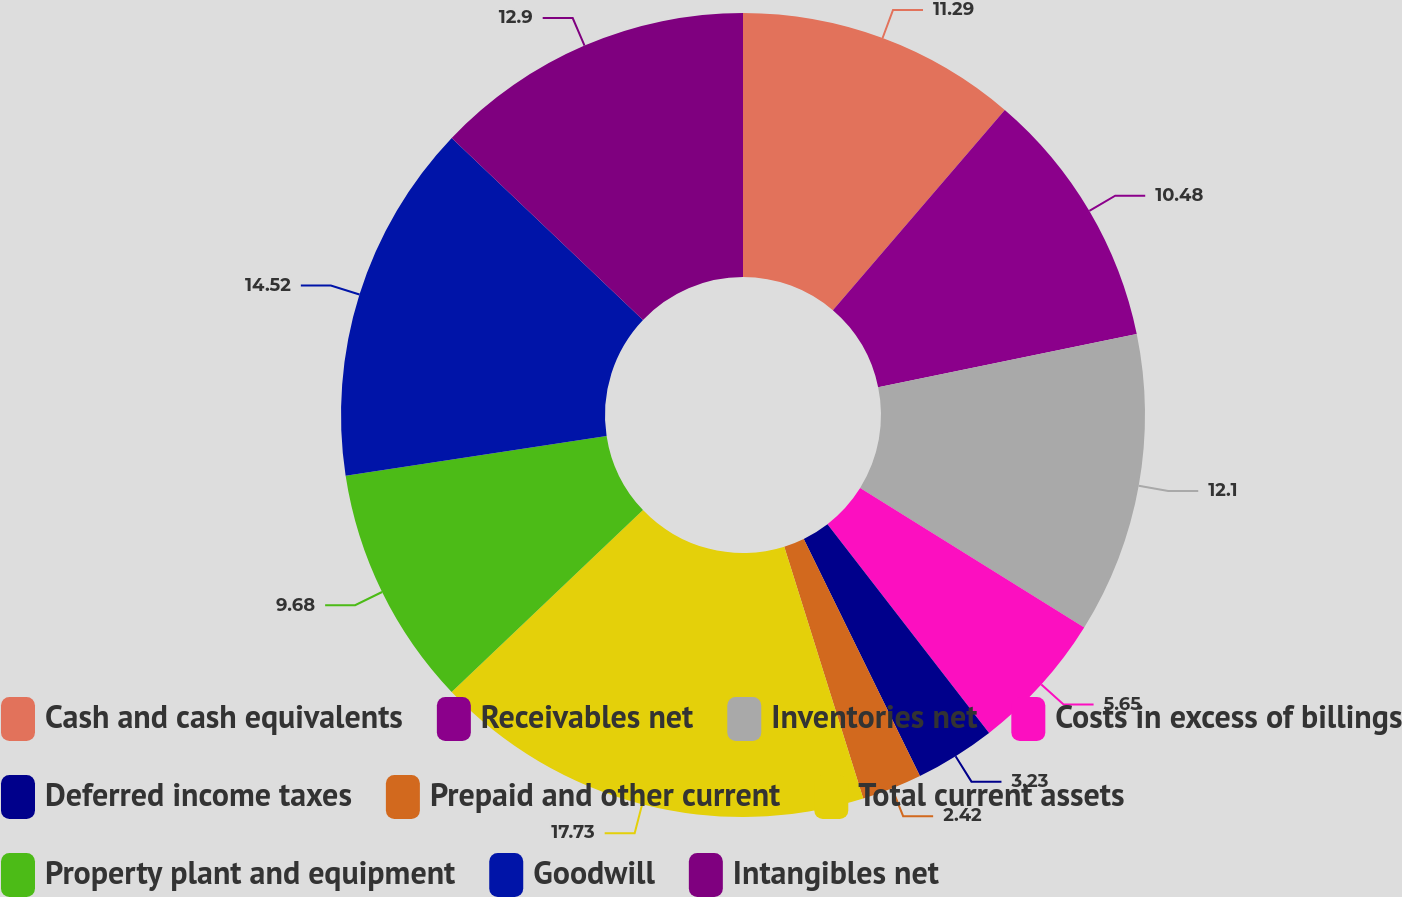Convert chart to OTSL. <chart><loc_0><loc_0><loc_500><loc_500><pie_chart><fcel>Cash and cash equivalents<fcel>Receivables net<fcel>Inventories net<fcel>Costs in excess of billings<fcel>Deferred income taxes<fcel>Prepaid and other current<fcel>Total current assets<fcel>Property plant and equipment<fcel>Goodwill<fcel>Intangibles net<nl><fcel>11.29%<fcel>10.48%<fcel>12.1%<fcel>5.65%<fcel>3.23%<fcel>2.42%<fcel>17.74%<fcel>9.68%<fcel>14.52%<fcel>12.9%<nl></chart> 